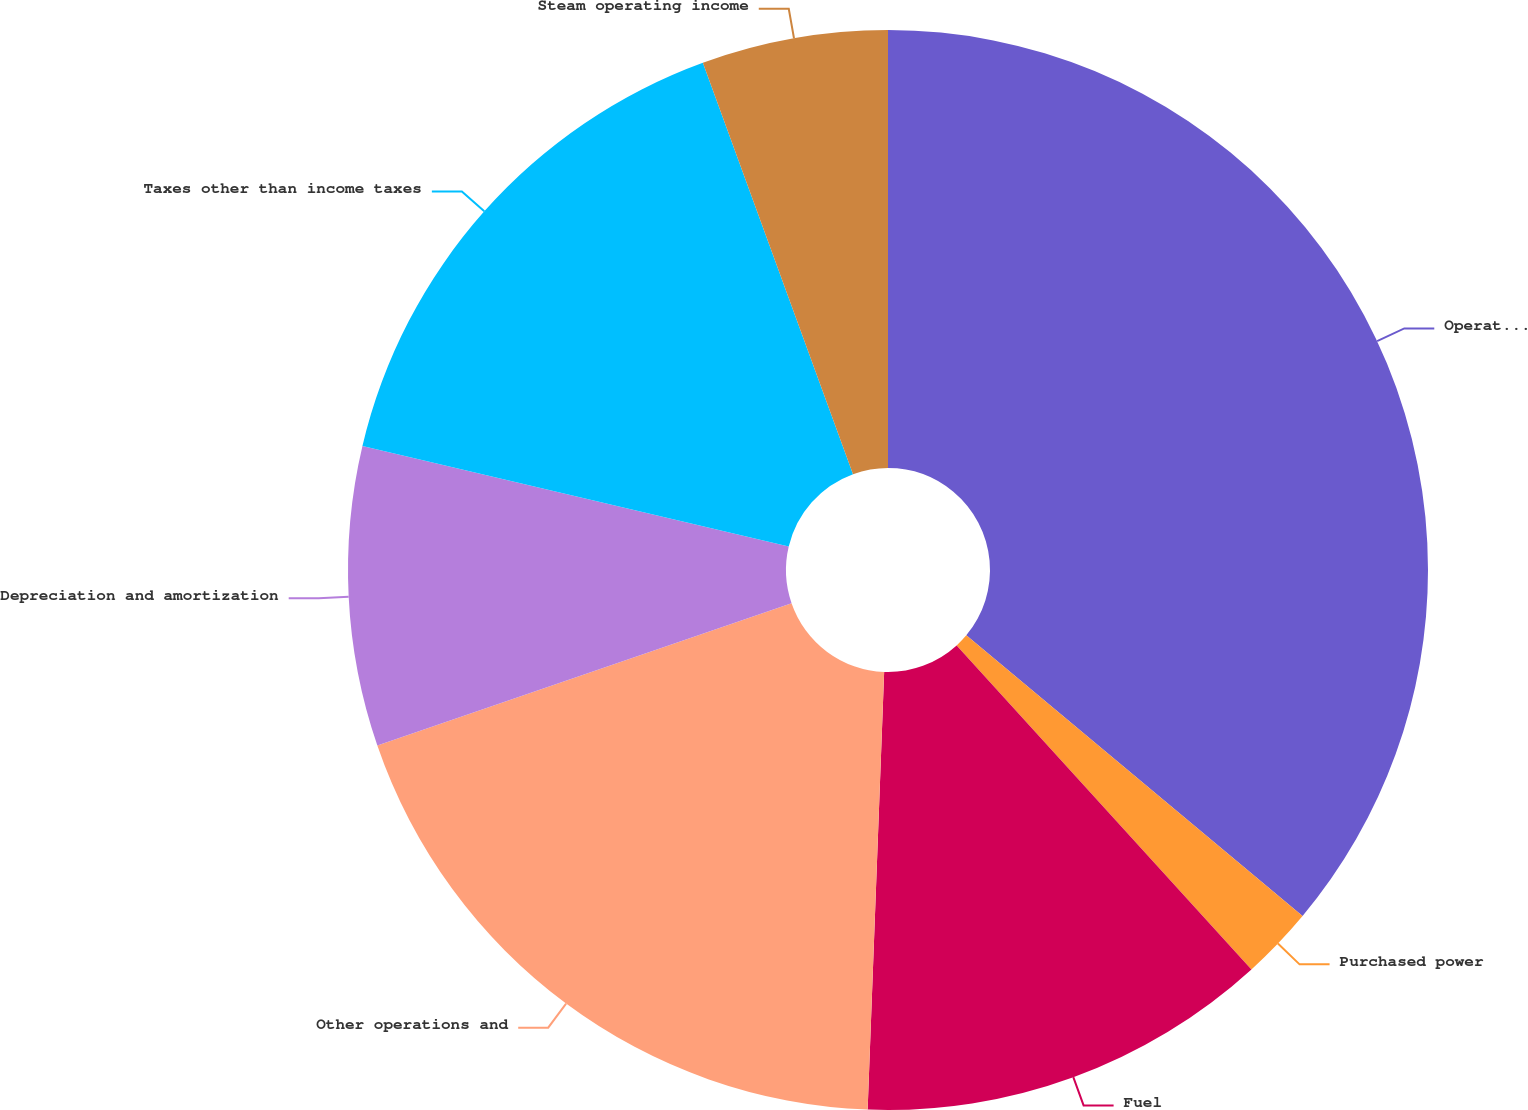Convert chart. <chart><loc_0><loc_0><loc_500><loc_500><pie_chart><fcel>Operating revenues<fcel>Purchased power<fcel>Fuel<fcel>Other operations and<fcel>Depreciation and amortization<fcel>Taxes other than income taxes<fcel>Steam operating income<nl><fcel>36.07%<fcel>2.18%<fcel>12.35%<fcel>19.13%<fcel>8.96%<fcel>15.74%<fcel>5.57%<nl></chart> 